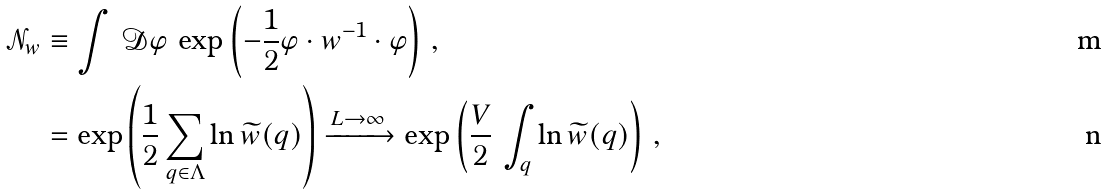<formula> <loc_0><loc_0><loc_500><loc_500>\mathcal { N } _ { w } & \equiv \int \, \mathcal { D } \varphi \, \exp \left ( - \frac { 1 } { 2 } \varphi \cdot w ^ { - 1 } \cdot \varphi \right ) \, , \\ & = \exp \left ( \frac { 1 } { 2 } \sum _ { q \in \Lambda } \ln \widetilde { w } ( q ) \right ) \xrightarrow { L \to \infty } \exp \left ( \frac { V } { 2 } \, \int _ { q } \ln \widetilde { w } ( q ) \right ) \, ,</formula> 